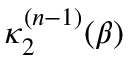Convert formula to latex. <formula><loc_0><loc_0><loc_500><loc_500>\kappa _ { 2 } ^ { ( n - 1 ) } ( \beta )</formula> 